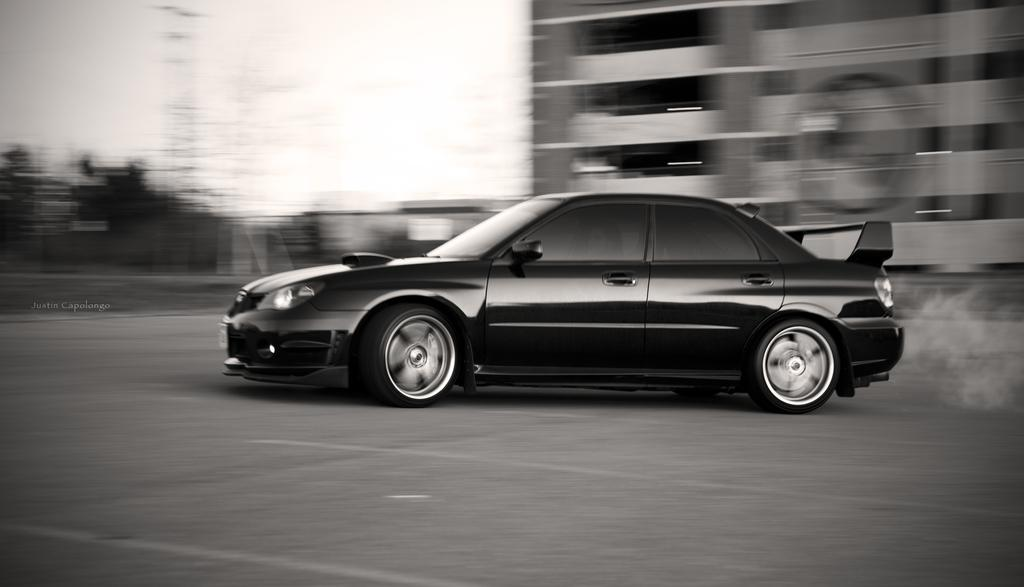What is the color scheme of the image? The image is black and white. What can be seen on the road in the image? There is a vehicle on the road in the image. What type of structure is present in the image? There is a building in the image. What is visible in the background of the image? The sky is visible in the background of the image. What type of cabbage is being used as a flavor enhancer in the image? There is no cabbage or mention of flavor enhancers in the image; it is a black and white image featuring a vehicle on the road and a building. How many bikes are visible in the image? There are no bikes present in the image. 